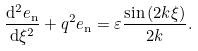Convert formula to latex. <formula><loc_0><loc_0><loc_500><loc_500>\frac { \mathrm d ^ { 2 } e _ { \mathrm n } } { \mathrm d \xi ^ { 2 } } + q ^ { 2 } e _ { \mathrm n } = \varepsilon \frac { \sin { ( 2 k \xi ) } } { 2 k } .</formula> 